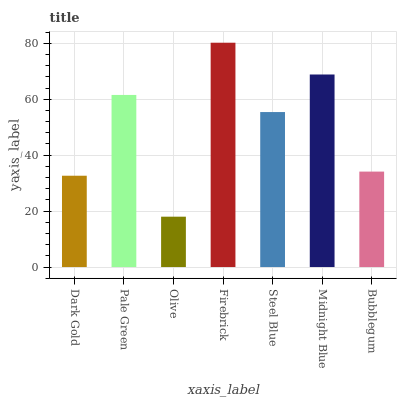Is Olive the minimum?
Answer yes or no. Yes. Is Firebrick the maximum?
Answer yes or no. Yes. Is Pale Green the minimum?
Answer yes or no. No. Is Pale Green the maximum?
Answer yes or no. No. Is Pale Green greater than Dark Gold?
Answer yes or no. Yes. Is Dark Gold less than Pale Green?
Answer yes or no. Yes. Is Dark Gold greater than Pale Green?
Answer yes or no. No. Is Pale Green less than Dark Gold?
Answer yes or no. No. Is Steel Blue the high median?
Answer yes or no. Yes. Is Steel Blue the low median?
Answer yes or no. Yes. Is Olive the high median?
Answer yes or no. No. Is Dark Gold the low median?
Answer yes or no. No. 